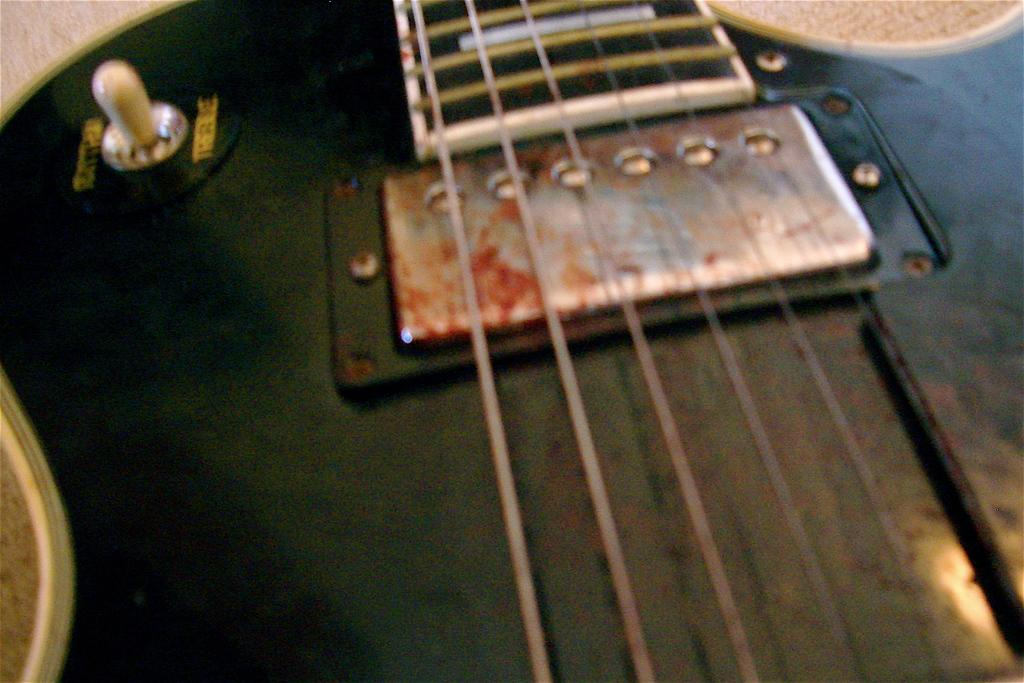What musical instrument is present in the image? There is a guitar in the image. What feature of the guitar is mentioned in the facts? The guitar has strings. Can you describe any text visible in the image? There is some text in the top left corner of the image. What type of jeans is the guitar wearing in the image? There are no jeans present in the image, as the subject is a guitar, which is an inanimate object and cannot wear clothing. 